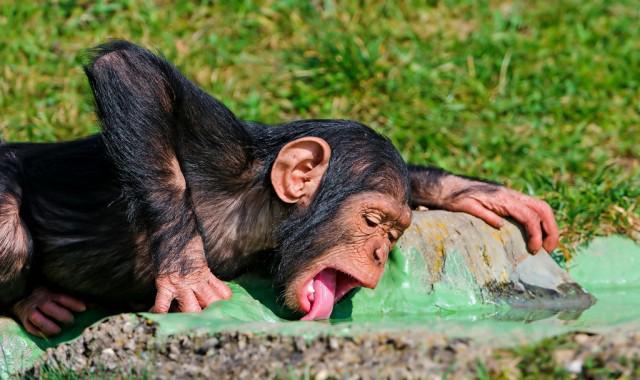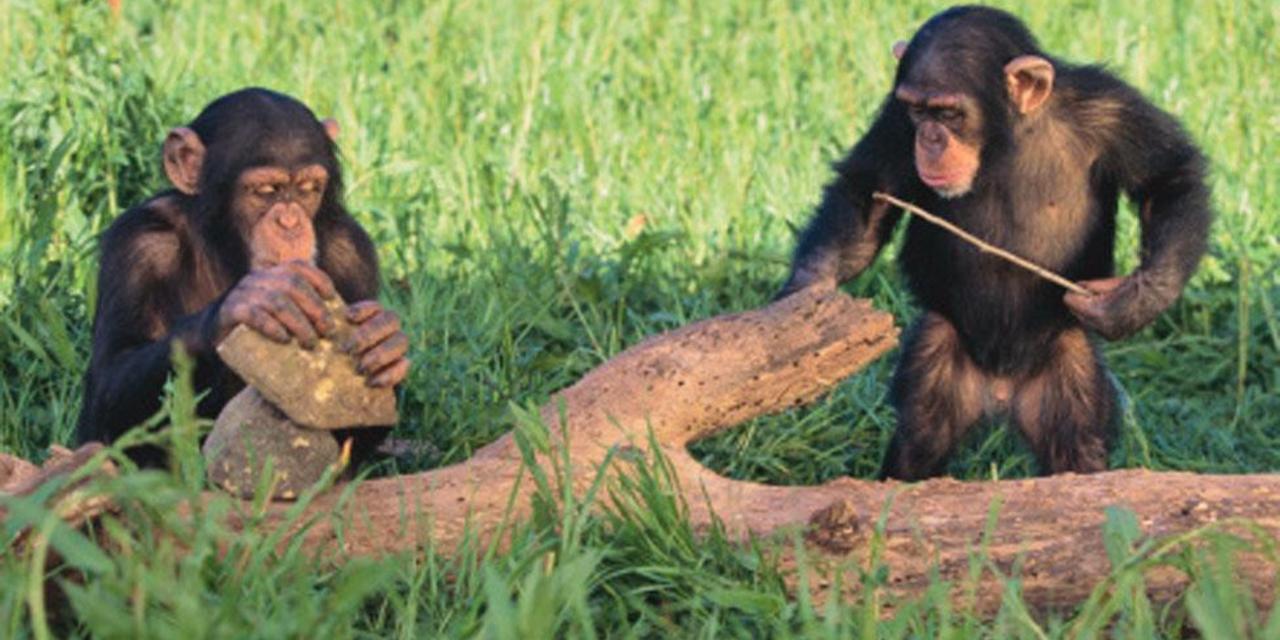The first image is the image on the left, the second image is the image on the right. For the images displayed, is the sentence "The right image contains exactly two chimpanzees." factually correct? Answer yes or no. Yes. The first image is the image on the left, the second image is the image on the right. Considering the images on both sides, is "One image shows no more than three chimps, who are near one another in a grassy field,  and the other image includes a chimp at the edge of a small pool sunken in the ground." valid? Answer yes or no. Yes. 